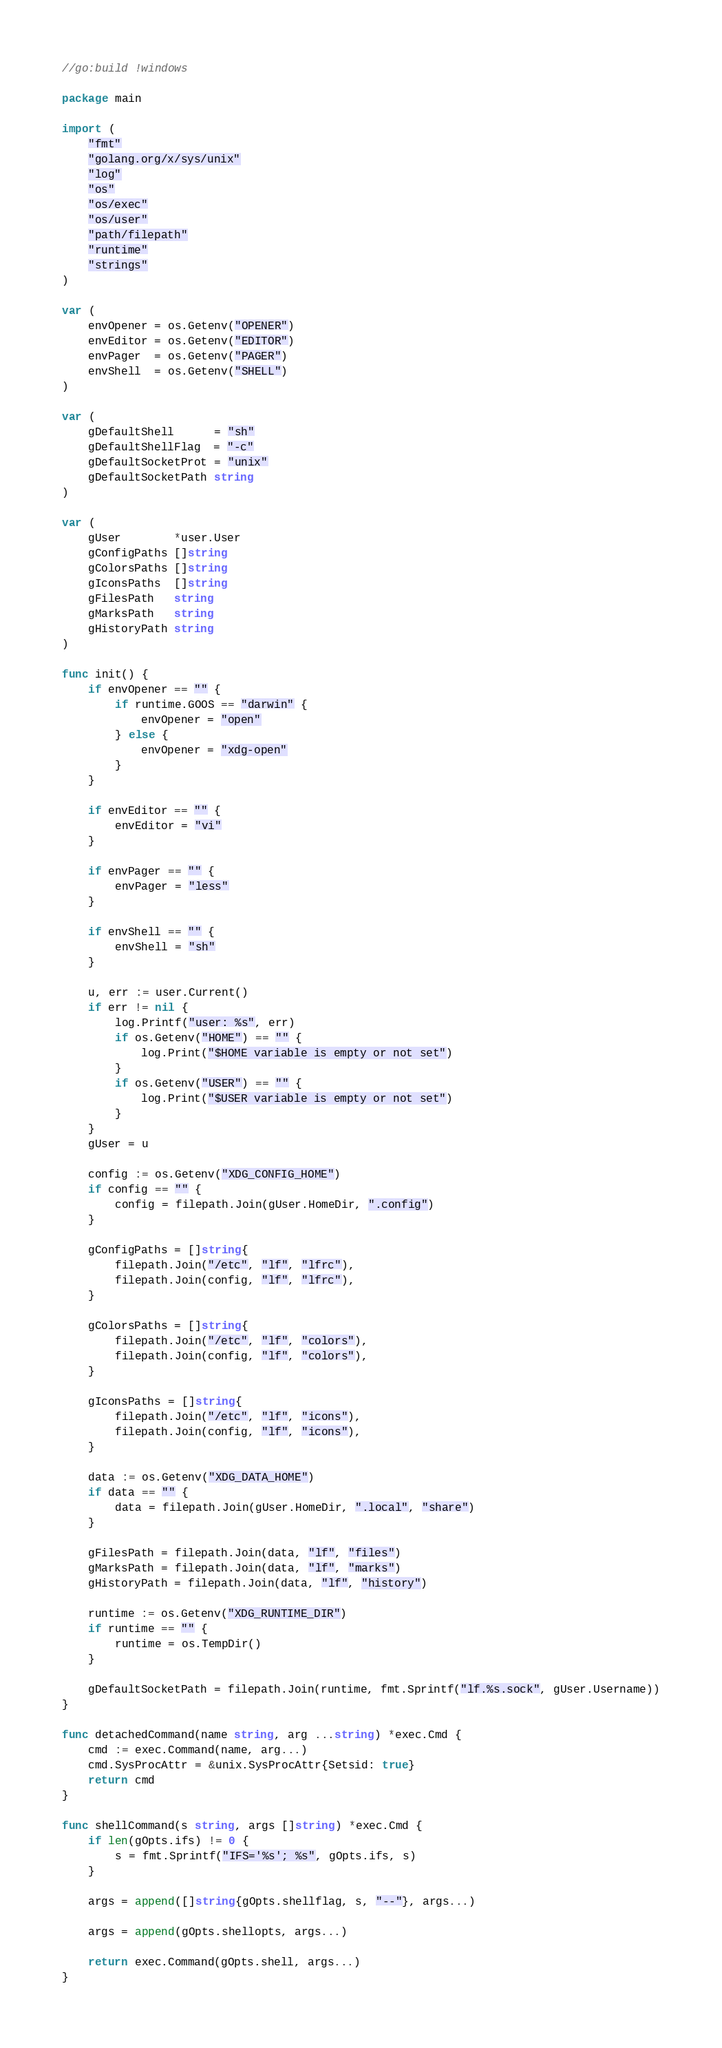<code> <loc_0><loc_0><loc_500><loc_500><_Go_>//go:build !windows

package main

import (
	"fmt"
	"golang.org/x/sys/unix"
	"log"
	"os"
	"os/exec"
	"os/user"
	"path/filepath"
	"runtime"
	"strings"
)

var (
	envOpener = os.Getenv("OPENER")
	envEditor = os.Getenv("EDITOR")
	envPager  = os.Getenv("PAGER")
	envShell  = os.Getenv("SHELL")
)

var (
	gDefaultShell      = "sh"
	gDefaultShellFlag  = "-c"
	gDefaultSocketProt = "unix"
	gDefaultSocketPath string
)

var (
	gUser        *user.User
	gConfigPaths []string
	gColorsPaths []string
	gIconsPaths  []string
	gFilesPath   string
	gMarksPath   string
	gHistoryPath string
)

func init() {
	if envOpener == "" {
		if runtime.GOOS == "darwin" {
			envOpener = "open"
		} else {
			envOpener = "xdg-open"
		}
	}

	if envEditor == "" {
		envEditor = "vi"
	}

	if envPager == "" {
		envPager = "less"
	}

	if envShell == "" {
		envShell = "sh"
	}

	u, err := user.Current()
	if err != nil {
		log.Printf("user: %s", err)
		if os.Getenv("HOME") == "" {
			log.Print("$HOME variable is empty or not set")
		}
		if os.Getenv("USER") == "" {
			log.Print("$USER variable is empty or not set")
		}
	}
	gUser = u

	config := os.Getenv("XDG_CONFIG_HOME")
	if config == "" {
		config = filepath.Join(gUser.HomeDir, ".config")
	}

	gConfigPaths = []string{
		filepath.Join("/etc", "lf", "lfrc"),
		filepath.Join(config, "lf", "lfrc"),
	}

	gColorsPaths = []string{
		filepath.Join("/etc", "lf", "colors"),
		filepath.Join(config, "lf", "colors"),
	}

	gIconsPaths = []string{
		filepath.Join("/etc", "lf", "icons"),
		filepath.Join(config, "lf", "icons"),
	}

	data := os.Getenv("XDG_DATA_HOME")
	if data == "" {
		data = filepath.Join(gUser.HomeDir, ".local", "share")
	}

	gFilesPath = filepath.Join(data, "lf", "files")
	gMarksPath = filepath.Join(data, "lf", "marks")
	gHistoryPath = filepath.Join(data, "lf", "history")

	runtime := os.Getenv("XDG_RUNTIME_DIR")
	if runtime == "" {
		runtime = os.TempDir()
	}

	gDefaultSocketPath = filepath.Join(runtime, fmt.Sprintf("lf.%s.sock", gUser.Username))
}

func detachedCommand(name string, arg ...string) *exec.Cmd {
	cmd := exec.Command(name, arg...)
	cmd.SysProcAttr = &unix.SysProcAttr{Setsid: true}
	return cmd
}

func shellCommand(s string, args []string) *exec.Cmd {
	if len(gOpts.ifs) != 0 {
		s = fmt.Sprintf("IFS='%s'; %s", gOpts.ifs, s)
	}

	args = append([]string{gOpts.shellflag, s, "--"}, args...)

	args = append(gOpts.shellopts, args...)

	return exec.Command(gOpts.shell, args...)
}
</code> 